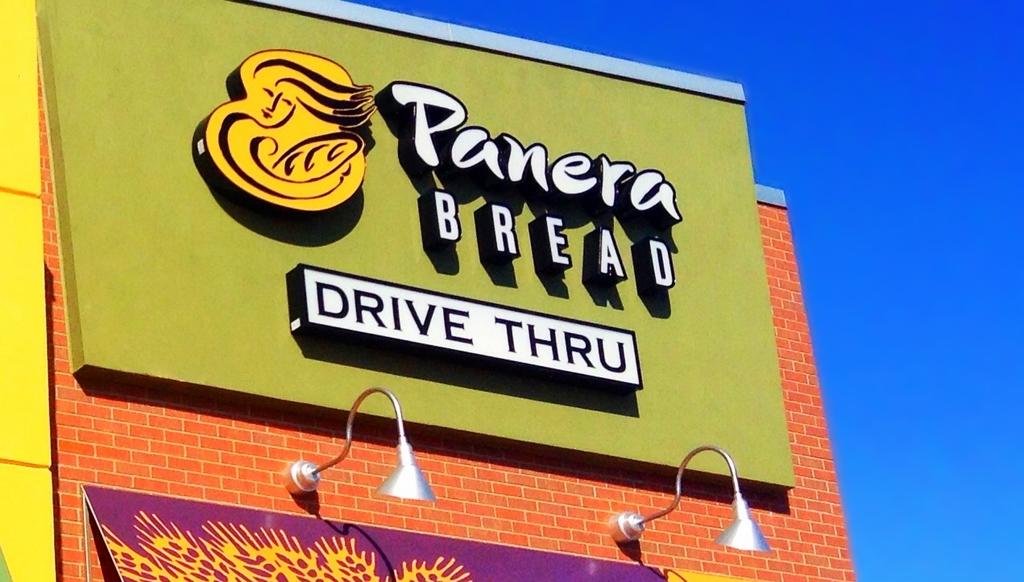What is under the restaurant name?
Your answer should be very brief. Drive thru. 